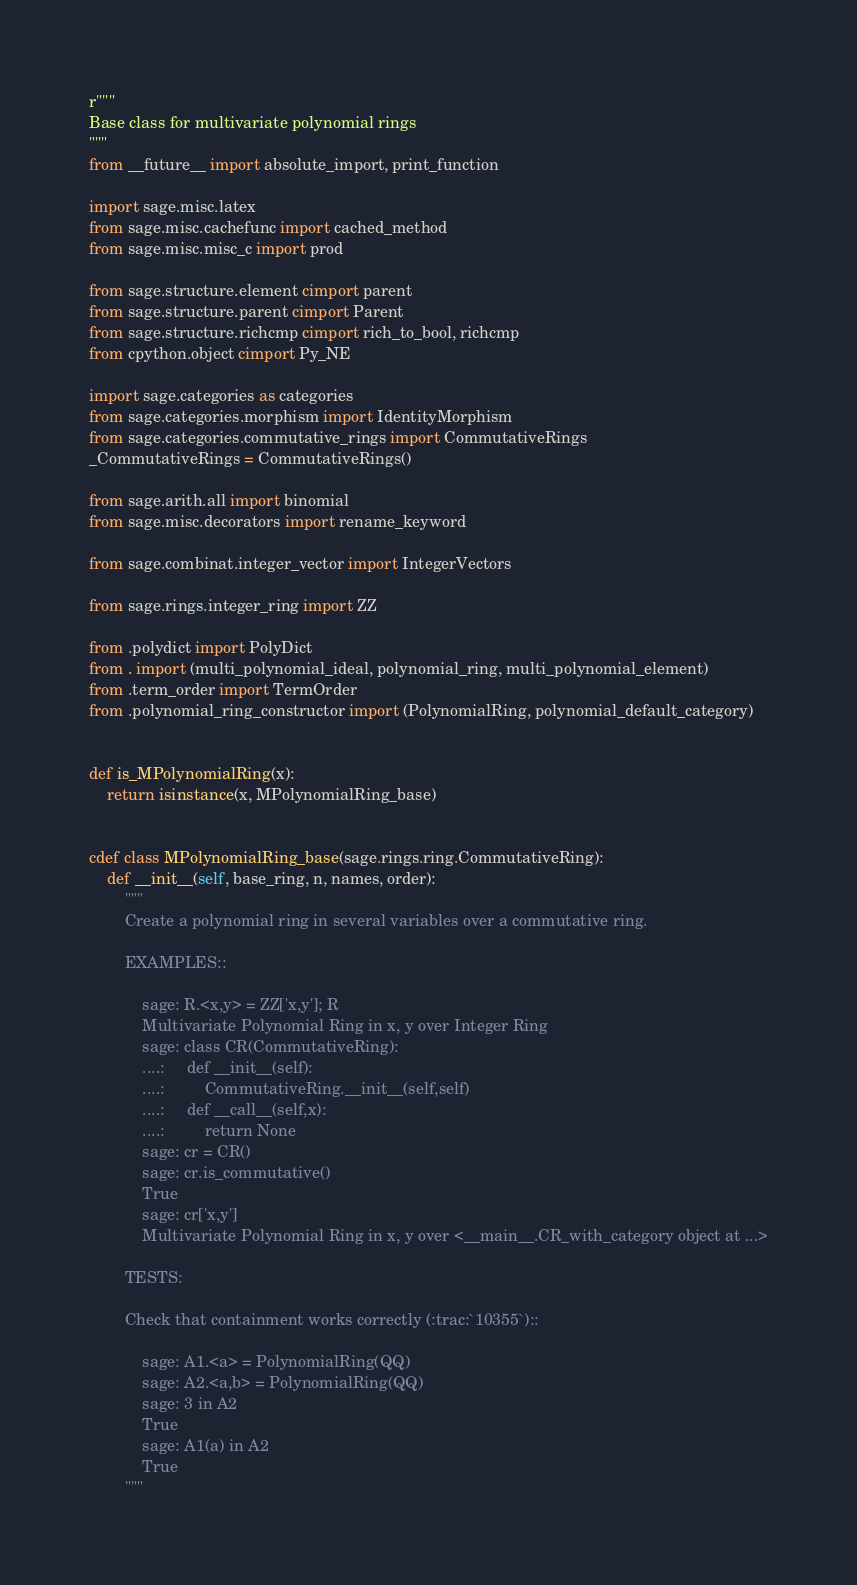<code> <loc_0><loc_0><loc_500><loc_500><_Cython_>r"""
Base class for multivariate polynomial rings
"""
from __future__ import absolute_import, print_function

import sage.misc.latex
from sage.misc.cachefunc import cached_method
from sage.misc.misc_c import prod

from sage.structure.element cimport parent
from sage.structure.parent cimport Parent
from sage.structure.richcmp cimport rich_to_bool, richcmp
from cpython.object cimport Py_NE

import sage.categories as categories
from sage.categories.morphism import IdentityMorphism
from sage.categories.commutative_rings import CommutativeRings
_CommutativeRings = CommutativeRings()

from sage.arith.all import binomial
from sage.misc.decorators import rename_keyword

from sage.combinat.integer_vector import IntegerVectors

from sage.rings.integer_ring import ZZ

from .polydict import PolyDict
from . import (multi_polynomial_ideal, polynomial_ring, multi_polynomial_element)
from .term_order import TermOrder
from .polynomial_ring_constructor import (PolynomialRing, polynomial_default_category)


def is_MPolynomialRing(x):
    return isinstance(x, MPolynomialRing_base)


cdef class MPolynomialRing_base(sage.rings.ring.CommutativeRing):
    def __init__(self, base_ring, n, names, order):
        """
        Create a polynomial ring in several variables over a commutative ring.

        EXAMPLES::

            sage: R.<x,y> = ZZ['x,y']; R
            Multivariate Polynomial Ring in x, y over Integer Ring
            sage: class CR(CommutativeRing):
            ....:     def __init__(self):
            ....:         CommutativeRing.__init__(self,self)
            ....:     def __call__(self,x):
            ....:         return None
            sage: cr = CR()
            sage: cr.is_commutative()
            True
            sage: cr['x,y']
            Multivariate Polynomial Ring in x, y over <__main__.CR_with_category object at ...>

        TESTS:

        Check that containment works correctly (:trac:`10355`)::

            sage: A1.<a> = PolynomialRing(QQ)
            sage: A2.<a,b> = PolynomialRing(QQ)
            sage: 3 in A2
            True
            sage: A1(a) in A2
            True
        """</code> 